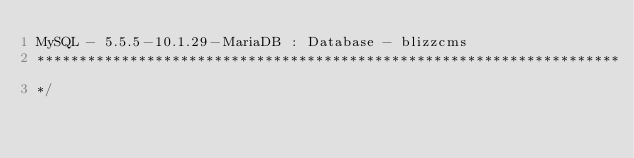Convert code to text. <code><loc_0><loc_0><loc_500><loc_500><_SQL_>MySQL - 5.5.5-10.1.29-MariaDB : Database - blizzcms
*********************************************************************
*/
</code> 